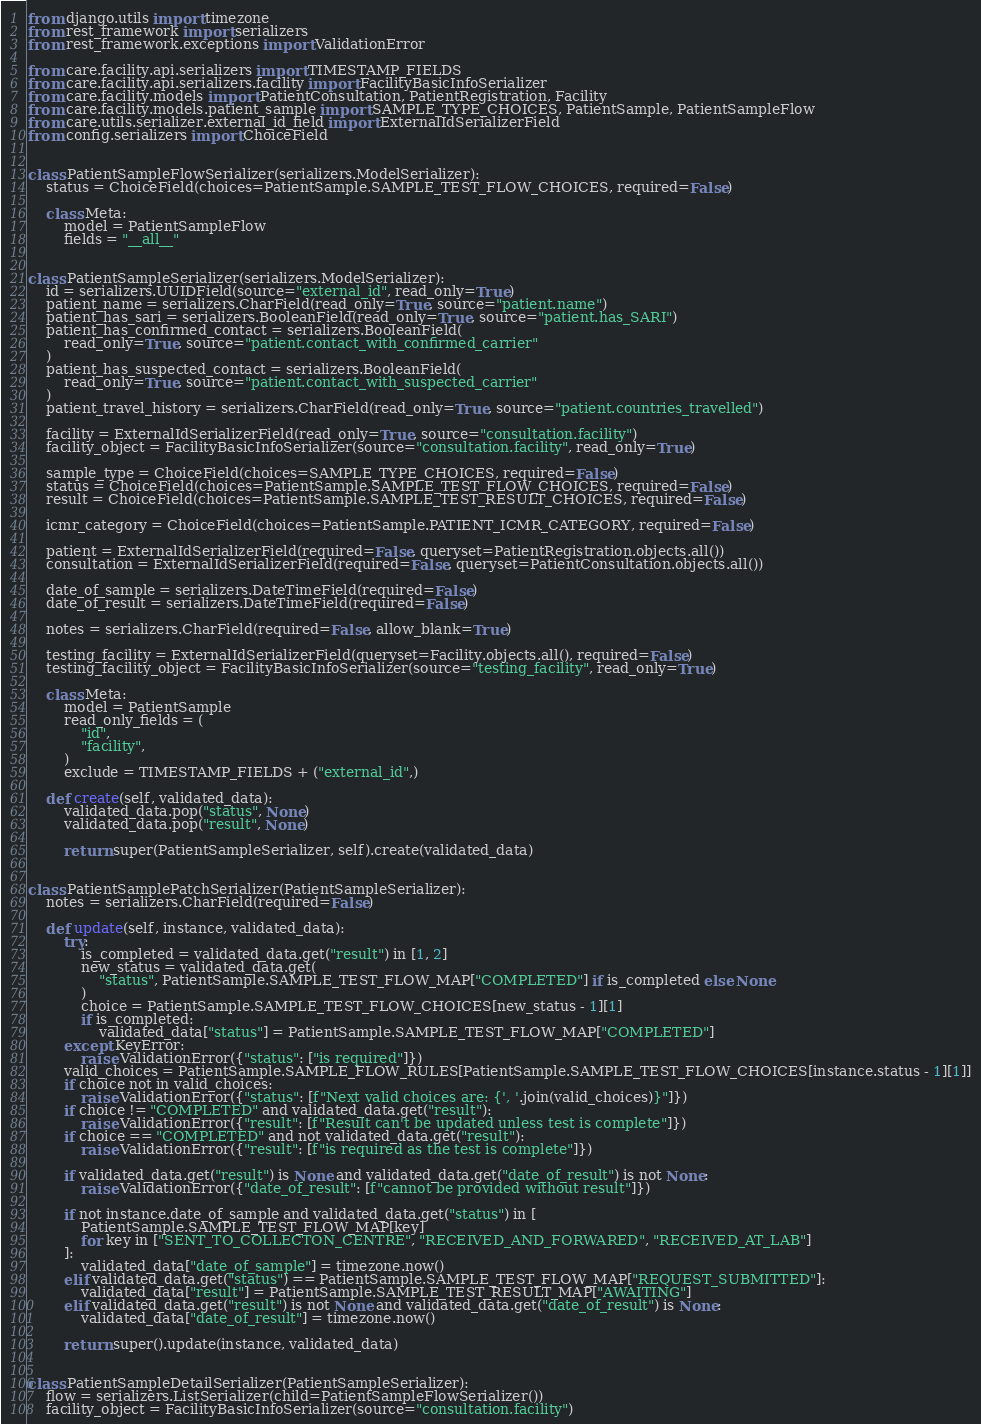Convert code to text. <code><loc_0><loc_0><loc_500><loc_500><_Python_>from django.utils import timezone
from rest_framework import serializers
from rest_framework.exceptions import ValidationError

from care.facility.api.serializers import TIMESTAMP_FIELDS
from care.facility.api.serializers.facility import FacilityBasicInfoSerializer
from care.facility.models import PatientConsultation, PatientRegistration, Facility
from care.facility.models.patient_sample import SAMPLE_TYPE_CHOICES, PatientSample, PatientSampleFlow
from care.utils.serializer.external_id_field import ExternalIdSerializerField
from config.serializers import ChoiceField


class PatientSampleFlowSerializer(serializers.ModelSerializer):
    status = ChoiceField(choices=PatientSample.SAMPLE_TEST_FLOW_CHOICES, required=False)

    class Meta:
        model = PatientSampleFlow
        fields = "__all__"


class PatientSampleSerializer(serializers.ModelSerializer):
    id = serializers.UUIDField(source="external_id", read_only=True)
    patient_name = serializers.CharField(read_only=True, source="patient.name")
    patient_has_sari = serializers.BooleanField(read_only=True, source="patient.has_SARI")
    patient_has_confirmed_contact = serializers.BooleanField(
        read_only=True, source="patient.contact_with_confirmed_carrier"
    )
    patient_has_suspected_contact = serializers.BooleanField(
        read_only=True, source="patient.contact_with_suspected_carrier"
    )
    patient_travel_history = serializers.CharField(read_only=True, source="patient.countries_travelled")

    facility = ExternalIdSerializerField(read_only=True, source="consultation.facility")
    facility_object = FacilityBasicInfoSerializer(source="consultation.facility", read_only=True)

    sample_type = ChoiceField(choices=SAMPLE_TYPE_CHOICES, required=False)
    status = ChoiceField(choices=PatientSample.SAMPLE_TEST_FLOW_CHOICES, required=False)
    result = ChoiceField(choices=PatientSample.SAMPLE_TEST_RESULT_CHOICES, required=False)

    icmr_category = ChoiceField(choices=PatientSample.PATIENT_ICMR_CATEGORY, required=False)

    patient = ExternalIdSerializerField(required=False, queryset=PatientRegistration.objects.all())
    consultation = ExternalIdSerializerField(required=False, queryset=PatientConsultation.objects.all())

    date_of_sample = serializers.DateTimeField(required=False)
    date_of_result = serializers.DateTimeField(required=False)

    notes = serializers.CharField(required=False, allow_blank=True)

    testing_facility = ExternalIdSerializerField(queryset=Facility.objects.all(), required=False)
    testing_facility_object = FacilityBasicInfoSerializer(source="testing_facility", read_only=True)

    class Meta:
        model = PatientSample
        read_only_fields = (
            "id",
            "facility",
        )
        exclude = TIMESTAMP_FIELDS + ("external_id",)

    def create(self, validated_data):
        validated_data.pop("status", None)
        validated_data.pop("result", None)

        return super(PatientSampleSerializer, self).create(validated_data)


class PatientSamplePatchSerializer(PatientSampleSerializer):
    notes = serializers.CharField(required=False)

    def update(self, instance, validated_data):
        try:
            is_completed = validated_data.get("result") in [1, 2]
            new_status = validated_data.get(
                "status", PatientSample.SAMPLE_TEST_FLOW_MAP["COMPLETED"] if is_completed else None
            )
            choice = PatientSample.SAMPLE_TEST_FLOW_CHOICES[new_status - 1][1]
            if is_completed:
                validated_data["status"] = PatientSample.SAMPLE_TEST_FLOW_MAP["COMPLETED"]
        except KeyError:
            raise ValidationError({"status": ["is required"]})
        valid_choices = PatientSample.SAMPLE_FLOW_RULES[PatientSample.SAMPLE_TEST_FLOW_CHOICES[instance.status - 1][1]]
        if choice not in valid_choices:
            raise ValidationError({"status": [f"Next valid choices are: {', '.join(valid_choices)}"]})
        if choice != "COMPLETED" and validated_data.get("result"):
            raise ValidationError({"result": [f"Result can't be updated unless test is complete"]})
        if choice == "COMPLETED" and not validated_data.get("result"):
            raise ValidationError({"result": [f"is required as the test is complete"]})

        if validated_data.get("result") is None and validated_data.get("date_of_result") is not None:
            raise ValidationError({"date_of_result": [f"cannot be provided without result"]})

        if not instance.date_of_sample and validated_data.get("status") in [
            PatientSample.SAMPLE_TEST_FLOW_MAP[key]
            for key in ["SENT_TO_COLLECTON_CENTRE", "RECEIVED_AND_FORWARED", "RECEIVED_AT_LAB"]
        ]:
            validated_data["date_of_sample"] = timezone.now()
        elif validated_data.get("status") == PatientSample.SAMPLE_TEST_FLOW_MAP["REQUEST_SUBMITTED"]:
            validated_data["result"] = PatientSample.SAMPLE_TEST_RESULT_MAP["AWAITING"]
        elif validated_data.get("result") is not None and validated_data.get("date_of_result") is None:
            validated_data["date_of_result"] = timezone.now()

        return super().update(instance, validated_data)


class PatientSampleDetailSerializer(PatientSampleSerializer):
    flow = serializers.ListSerializer(child=PatientSampleFlowSerializer())
    facility_object = FacilityBasicInfoSerializer(source="consultation.facility")
</code> 